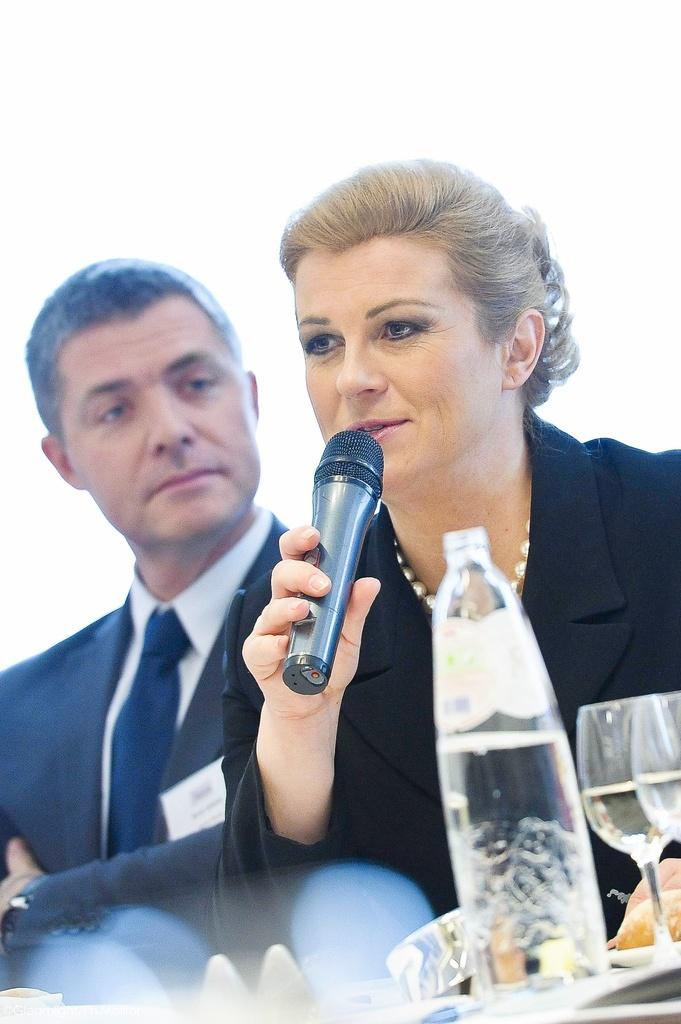Who are the people in the image? There is a man and a woman in the image. What is the woman doing in the image? The woman is talking on a microphone. What objects can be seen in the image besides the people? There is a bottle and glasses in the image. What is the color of the background in the image? The background of the image is white. What type of fiction is the woman writing on the chalkboard in the image? There is no chalkboard or fiction present in the image. How many heads are visible in the image? The image only shows one man and one woman, so there are two heads visible. 